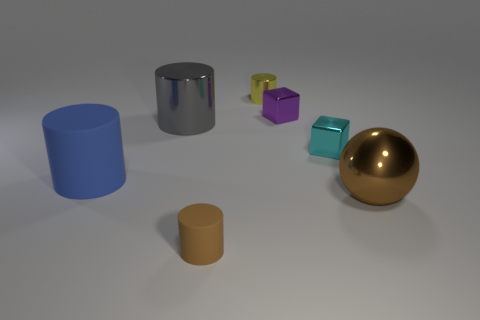Subtract all brown cylinders. How many cylinders are left? 3 Add 2 tiny brown matte cylinders. How many objects exist? 9 Subtract all purple cubes. How many cubes are left? 1 Subtract 2 cylinders. How many cylinders are left? 2 Subtract all red balls. How many green cylinders are left? 0 Subtract all blocks. How many objects are left? 5 Subtract all cyan cubes. Subtract all cyan cylinders. How many cubes are left? 1 Subtract all brown matte cylinders. Subtract all big blue rubber things. How many objects are left? 5 Add 3 big blue matte cylinders. How many big blue matte cylinders are left? 4 Add 2 large red rubber blocks. How many large red rubber blocks exist? 2 